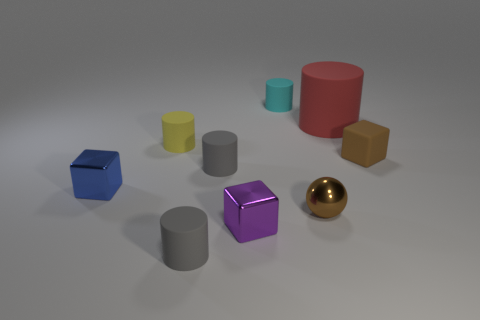Are there any brown matte blocks that have the same size as the yellow matte object?
Make the answer very short. Yes. There is a small block to the right of the cyan rubber cylinder; what number of blue shiny cubes are to the left of it?
Your response must be concise. 1. What is the material of the blue cube?
Make the answer very short. Metal. There is a cyan cylinder; what number of blue blocks are in front of it?
Your answer should be very brief. 1. Do the small metal sphere and the big object have the same color?
Provide a succinct answer. No. How many metal things are the same color as the ball?
Provide a succinct answer. 0. Are there more small cylinders than metallic blocks?
Make the answer very short. Yes. There is a thing that is both to the left of the purple metal cube and in front of the tiny shiny sphere; what size is it?
Provide a succinct answer. Small. Is the material of the tiny gray thing that is in front of the blue metal block the same as the small brown thing left of the big rubber cylinder?
Provide a short and direct response. No. There is a blue thing that is the same size as the yellow cylinder; what is its shape?
Provide a succinct answer. Cube. 